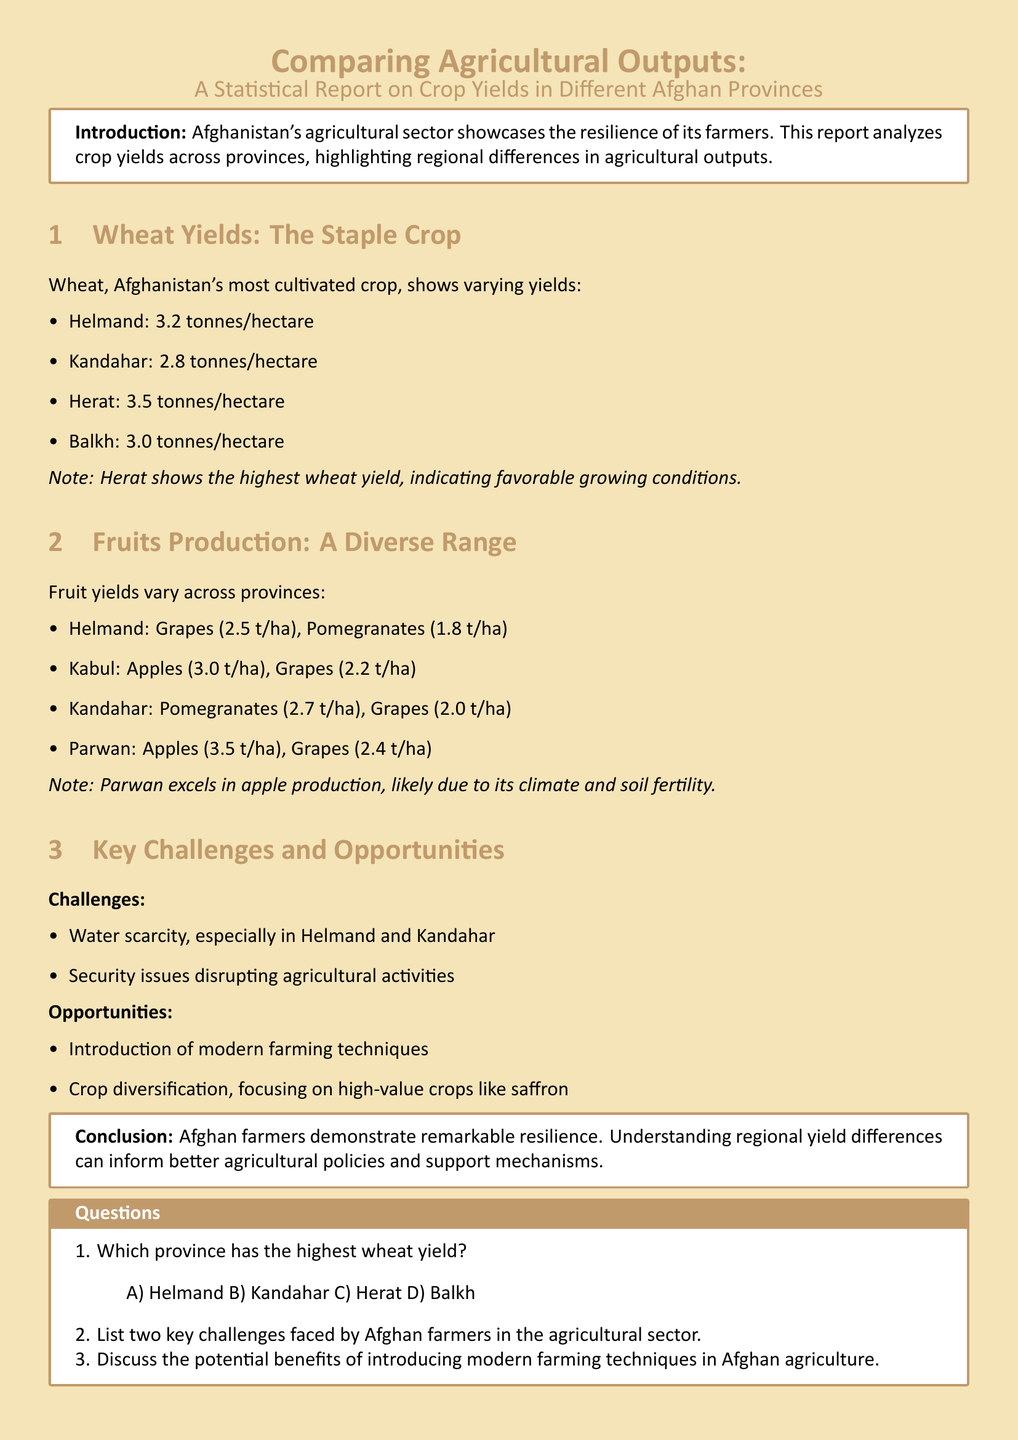Which province has the highest wheat yield? The highest wheat yield is found in Herat, according to the data provided in the report.
Answer: Herat What is the wheat yield in Helmand? The yield for wheat in Helmand is specifically stated as 3.2 tonnes/hectare in the report.
Answer: 3.2 tonnes/hectare Which province excels in apple production? The province that excels in apple production is Parwan, as highlighted in the fruits production section of the report.
Answer: Parwan What are two key challenges faced by Afghan farmers? The document specifies water scarcity and security issues as two key challenges impacting Afghan farmers.
Answer: Water scarcity, security issues What is the fruit yield for pomegranates in Kandahar? The report notes that Kandahar has a pomegranate yield of 2.7 tonnes/hectare, making this information relevant for understanding regional outputs.
Answer: 2.7 tonnes/hectare Which crop is suggested for crop diversification? The report mentions saffron as a high-value crop that could be pursued for diversification in Afghan agriculture.
Answer: Saffron What is the main crop discussed in the report? The main crop addressed in the document is wheat, which serves as a staple crop in Afghanistan.
Answer: Wheat What is the yield for apples in Kabul? The yield for apples in Kabul is listed at 3.0 tonnes/hectare, according to the details shown in the fruit production section of the report.
Answer: 3.0 tonnes/hectare 